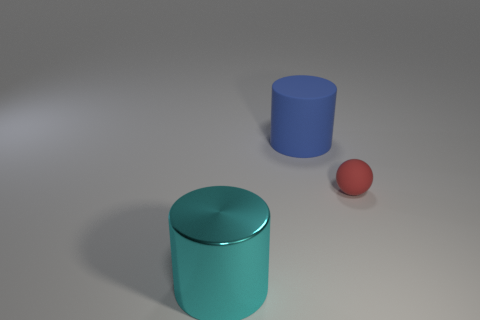How many objects are either blue cylinders that are on the right side of the cyan cylinder or tiny green matte cylinders?
Give a very brief answer. 1. Is there a cyan metal object that has the same size as the blue cylinder?
Ensure brevity in your answer.  Yes. There is a big thing in front of the matte ball; are there any large objects behind it?
Ensure brevity in your answer.  Yes. How many balls are large metal things or rubber things?
Provide a succinct answer. 1. Is there another big object that has the same shape as the large matte object?
Provide a succinct answer. Yes. The large metal thing is what shape?
Offer a terse response. Cylinder. What number of objects are either small blue matte spheres or big things?
Your answer should be compact. 2. There is a cylinder in front of the big blue cylinder; does it have the same size as the cylinder to the right of the cyan object?
Provide a short and direct response. Yes. How many other objects are the same material as the big cyan cylinder?
Offer a terse response. 0. Is the number of large cylinders that are to the right of the metallic cylinder greater than the number of red things in front of the small object?
Provide a succinct answer. Yes. 